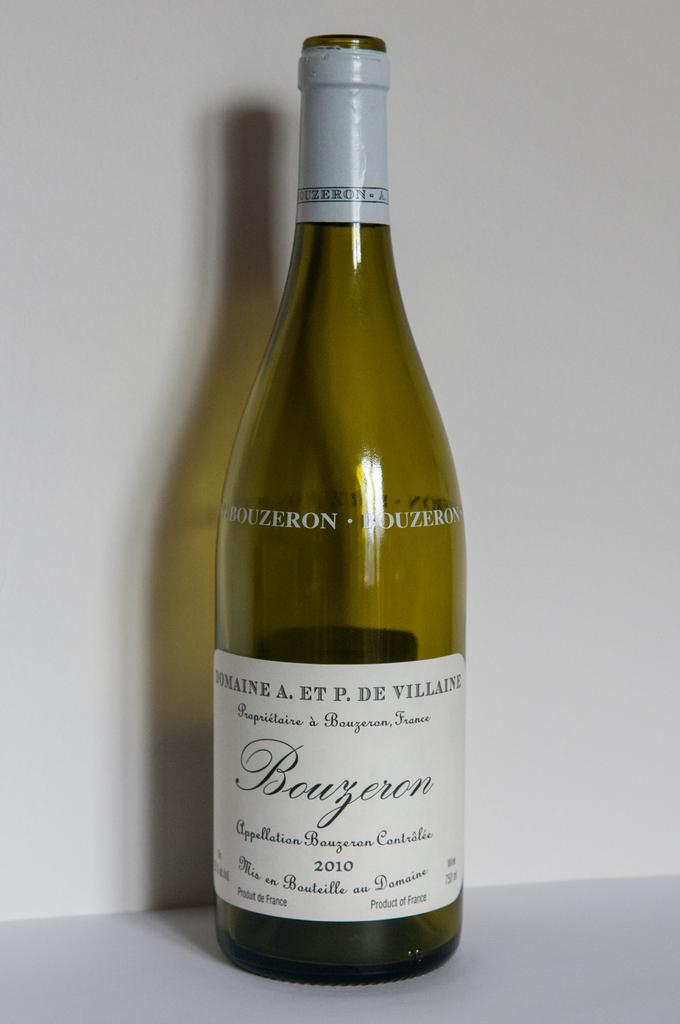<image>
Create a compact narrative representing the image presented. A 2010 Bouzoron wine bottle is being displayed in the picture. 